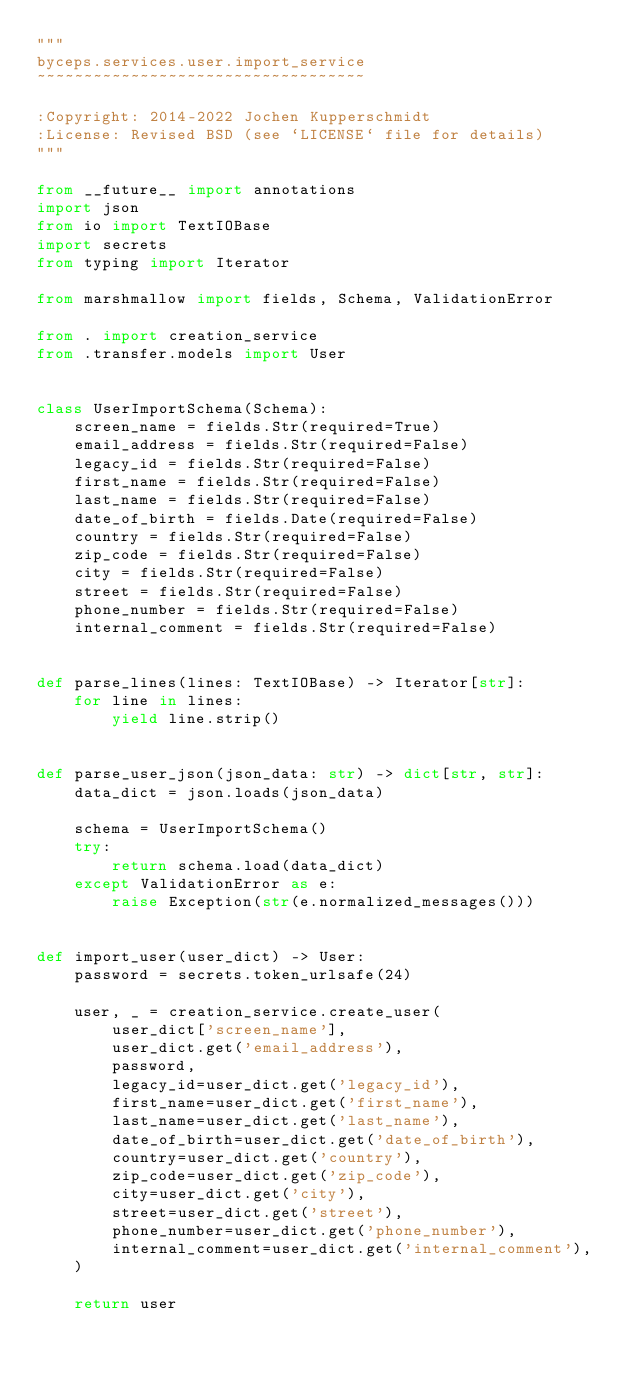Convert code to text. <code><loc_0><loc_0><loc_500><loc_500><_Python_>"""
byceps.services.user.import_service
~~~~~~~~~~~~~~~~~~~~~~~~~~~~~~~~~~~

:Copyright: 2014-2022 Jochen Kupperschmidt
:License: Revised BSD (see `LICENSE` file for details)
"""

from __future__ import annotations
import json
from io import TextIOBase
import secrets
from typing import Iterator

from marshmallow import fields, Schema, ValidationError

from . import creation_service
from .transfer.models import User


class UserImportSchema(Schema):
    screen_name = fields.Str(required=True)
    email_address = fields.Str(required=False)
    legacy_id = fields.Str(required=False)
    first_name = fields.Str(required=False)
    last_name = fields.Str(required=False)
    date_of_birth = fields.Date(required=False)
    country = fields.Str(required=False)
    zip_code = fields.Str(required=False)
    city = fields.Str(required=False)
    street = fields.Str(required=False)
    phone_number = fields.Str(required=False)
    internal_comment = fields.Str(required=False)


def parse_lines(lines: TextIOBase) -> Iterator[str]:
    for line in lines:
        yield line.strip()


def parse_user_json(json_data: str) -> dict[str, str]:
    data_dict = json.loads(json_data)

    schema = UserImportSchema()
    try:
        return schema.load(data_dict)
    except ValidationError as e:
        raise Exception(str(e.normalized_messages()))


def import_user(user_dict) -> User:
    password = secrets.token_urlsafe(24)

    user, _ = creation_service.create_user(
        user_dict['screen_name'],
        user_dict.get('email_address'),
        password,
        legacy_id=user_dict.get('legacy_id'),
        first_name=user_dict.get('first_name'),
        last_name=user_dict.get('last_name'),
        date_of_birth=user_dict.get('date_of_birth'),
        country=user_dict.get('country'),
        zip_code=user_dict.get('zip_code'),
        city=user_dict.get('city'),
        street=user_dict.get('street'),
        phone_number=user_dict.get('phone_number'),
        internal_comment=user_dict.get('internal_comment'),
    )

    return user
</code> 